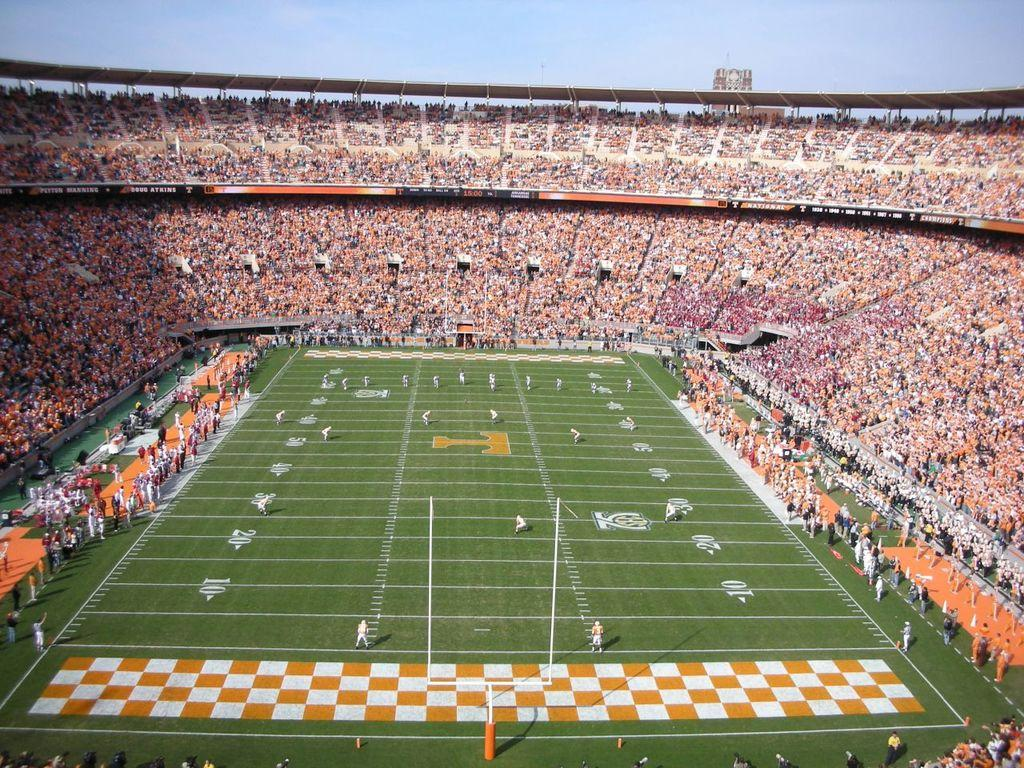<image>
Offer a succinct explanation of the picture presented. a mostly oranged filled football field for T national team 